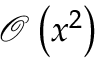Convert formula to latex. <formula><loc_0><loc_0><loc_500><loc_500>{ \mathcal { O } } \left ( x ^ { 2 } \right )</formula> 